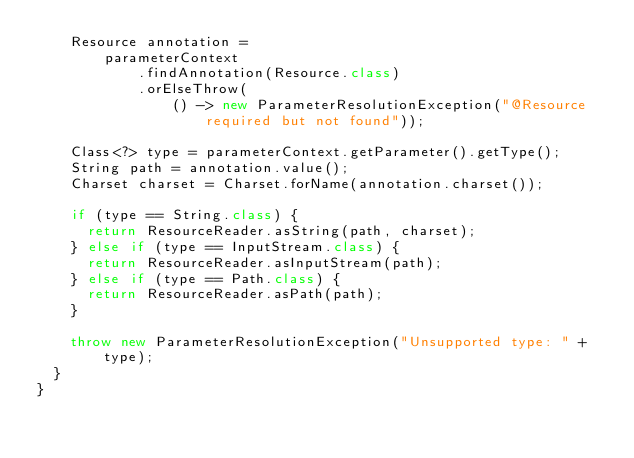Convert code to text. <code><loc_0><loc_0><loc_500><loc_500><_Java_>    Resource annotation =
        parameterContext
            .findAnnotation(Resource.class)
            .orElseThrow(
                () -> new ParameterResolutionException("@Resource required but not found"));

    Class<?> type = parameterContext.getParameter().getType();
    String path = annotation.value();
    Charset charset = Charset.forName(annotation.charset());

    if (type == String.class) {
      return ResourceReader.asString(path, charset);
    } else if (type == InputStream.class) {
      return ResourceReader.asInputStream(path);
    } else if (type == Path.class) {
      return ResourceReader.asPath(path);
    }

    throw new ParameterResolutionException("Unsupported type: " + type);
  }
}
</code> 